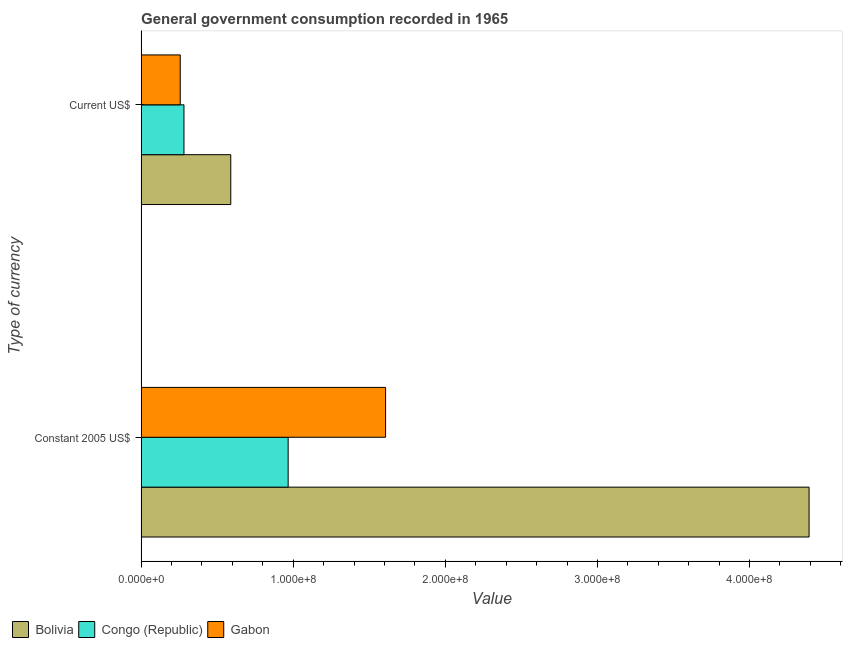How many different coloured bars are there?
Offer a terse response. 3. Are the number of bars on each tick of the Y-axis equal?
Provide a short and direct response. Yes. What is the label of the 2nd group of bars from the top?
Provide a short and direct response. Constant 2005 US$. What is the value consumed in current us$ in Bolivia?
Your response must be concise. 5.89e+07. Across all countries, what is the maximum value consumed in current us$?
Your answer should be very brief. 5.89e+07. Across all countries, what is the minimum value consumed in current us$?
Your answer should be very brief. 2.57e+07. In which country was the value consumed in current us$ maximum?
Make the answer very short. Bolivia. In which country was the value consumed in current us$ minimum?
Offer a very short reply. Gabon. What is the total value consumed in constant 2005 us$ in the graph?
Offer a terse response. 6.97e+08. What is the difference between the value consumed in constant 2005 us$ in Bolivia and that in Congo (Republic)?
Your response must be concise. 3.42e+08. What is the difference between the value consumed in constant 2005 us$ in Congo (Republic) and the value consumed in current us$ in Bolivia?
Keep it short and to the point. 3.77e+07. What is the average value consumed in constant 2005 us$ per country?
Keep it short and to the point. 2.32e+08. What is the difference between the value consumed in current us$ and value consumed in constant 2005 us$ in Bolivia?
Your answer should be compact. -3.80e+08. What is the ratio of the value consumed in constant 2005 us$ in Gabon to that in Bolivia?
Offer a terse response. 0.37. Is the value consumed in constant 2005 us$ in Gabon less than that in Bolivia?
Keep it short and to the point. Yes. In how many countries, is the value consumed in constant 2005 us$ greater than the average value consumed in constant 2005 us$ taken over all countries?
Your answer should be compact. 1. What does the 3rd bar from the top in Current US$ represents?
Ensure brevity in your answer.  Bolivia. What does the 1st bar from the bottom in Constant 2005 US$ represents?
Provide a succinct answer. Bolivia. Are all the bars in the graph horizontal?
Keep it short and to the point. Yes. How many countries are there in the graph?
Your response must be concise. 3. Does the graph contain any zero values?
Offer a very short reply. No. Where does the legend appear in the graph?
Make the answer very short. Bottom left. How many legend labels are there?
Keep it short and to the point. 3. How are the legend labels stacked?
Make the answer very short. Horizontal. What is the title of the graph?
Your answer should be very brief. General government consumption recorded in 1965. What is the label or title of the X-axis?
Your answer should be compact. Value. What is the label or title of the Y-axis?
Keep it short and to the point. Type of currency. What is the Value of Bolivia in Constant 2005 US$?
Keep it short and to the point. 4.39e+08. What is the Value in Congo (Republic) in Constant 2005 US$?
Keep it short and to the point. 9.66e+07. What is the Value of Gabon in Constant 2005 US$?
Your answer should be very brief. 1.61e+08. What is the Value of Bolivia in Current US$?
Your answer should be very brief. 5.89e+07. What is the Value of Congo (Republic) in Current US$?
Your answer should be very brief. 2.82e+07. What is the Value in Gabon in Current US$?
Provide a short and direct response. 2.57e+07. Across all Type of currency, what is the maximum Value in Bolivia?
Your response must be concise. 4.39e+08. Across all Type of currency, what is the maximum Value in Congo (Republic)?
Your answer should be very brief. 9.66e+07. Across all Type of currency, what is the maximum Value in Gabon?
Offer a very short reply. 1.61e+08. Across all Type of currency, what is the minimum Value in Bolivia?
Your response must be concise. 5.89e+07. Across all Type of currency, what is the minimum Value in Congo (Republic)?
Your answer should be compact. 2.82e+07. Across all Type of currency, what is the minimum Value of Gabon?
Ensure brevity in your answer.  2.57e+07. What is the total Value in Bolivia in the graph?
Your response must be concise. 4.98e+08. What is the total Value in Congo (Republic) in the graph?
Provide a succinct answer. 1.25e+08. What is the total Value of Gabon in the graph?
Give a very brief answer. 1.86e+08. What is the difference between the Value of Bolivia in Constant 2005 US$ and that in Current US$?
Keep it short and to the point. 3.80e+08. What is the difference between the Value in Congo (Republic) in Constant 2005 US$ and that in Current US$?
Your answer should be very brief. 6.85e+07. What is the difference between the Value of Gabon in Constant 2005 US$ and that in Current US$?
Make the answer very short. 1.35e+08. What is the difference between the Value in Bolivia in Constant 2005 US$ and the Value in Congo (Republic) in Current US$?
Offer a very short reply. 4.11e+08. What is the difference between the Value in Bolivia in Constant 2005 US$ and the Value in Gabon in Current US$?
Your answer should be very brief. 4.13e+08. What is the difference between the Value of Congo (Republic) in Constant 2005 US$ and the Value of Gabon in Current US$?
Make the answer very short. 7.09e+07. What is the average Value of Bolivia per Type of currency?
Ensure brevity in your answer.  2.49e+08. What is the average Value in Congo (Republic) per Type of currency?
Keep it short and to the point. 6.24e+07. What is the average Value of Gabon per Type of currency?
Your answer should be very brief. 9.32e+07. What is the difference between the Value of Bolivia and Value of Congo (Republic) in Constant 2005 US$?
Keep it short and to the point. 3.42e+08. What is the difference between the Value in Bolivia and Value in Gabon in Constant 2005 US$?
Your answer should be very brief. 2.78e+08. What is the difference between the Value in Congo (Republic) and Value in Gabon in Constant 2005 US$?
Give a very brief answer. -6.41e+07. What is the difference between the Value in Bolivia and Value in Congo (Republic) in Current US$?
Provide a short and direct response. 3.08e+07. What is the difference between the Value in Bolivia and Value in Gabon in Current US$?
Offer a terse response. 3.32e+07. What is the difference between the Value of Congo (Republic) and Value of Gabon in Current US$?
Provide a succinct answer. 2.45e+06. What is the ratio of the Value of Bolivia in Constant 2005 US$ to that in Current US$?
Offer a terse response. 7.45. What is the ratio of the Value of Congo (Republic) in Constant 2005 US$ to that in Current US$?
Give a very brief answer. 3.43. What is the ratio of the Value of Gabon in Constant 2005 US$ to that in Current US$?
Keep it short and to the point. 6.25. What is the difference between the highest and the second highest Value in Bolivia?
Provide a short and direct response. 3.80e+08. What is the difference between the highest and the second highest Value in Congo (Republic)?
Offer a very short reply. 6.85e+07. What is the difference between the highest and the second highest Value of Gabon?
Your response must be concise. 1.35e+08. What is the difference between the highest and the lowest Value in Bolivia?
Offer a terse response. 3.80e+08. What is the difference between the highest and the lowest Value in Congo (Republic)?
Your answer should be compact. 6.85e+07. What is the difference between the highest and the lowest Value in Gabon?
Make the answer very short. 1.35e+08. 